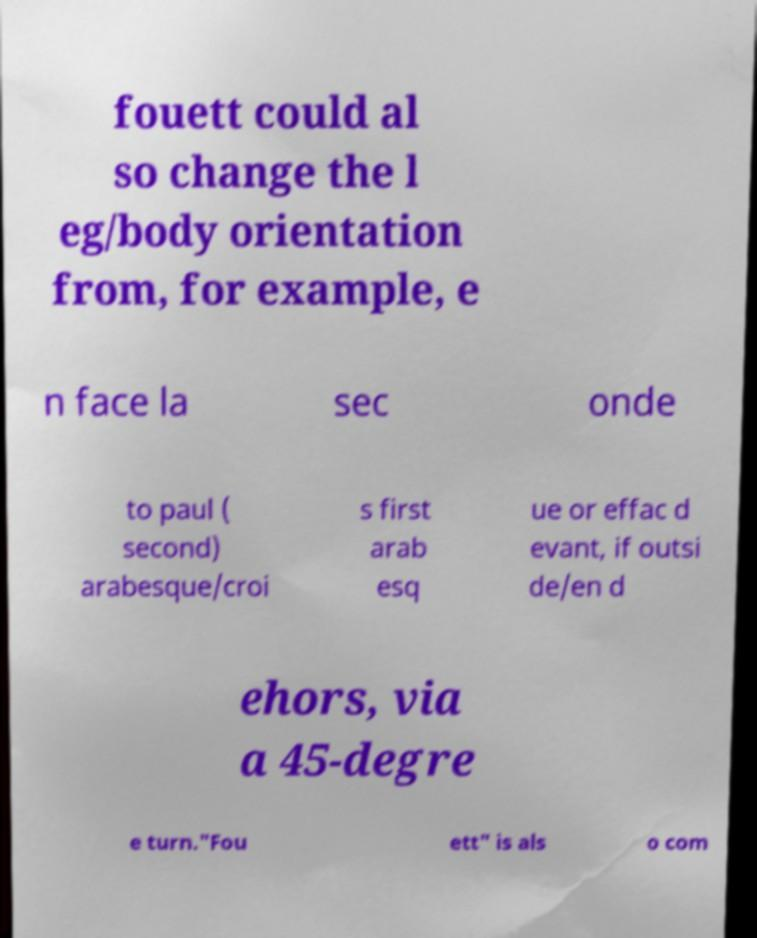For documentation purposes, I need the text within this image transcribed. Could you provide that? fouett could al so change the l eg/body orientation from, for example, e n face la sec onde to paul ( second) arabesque/croi s first arab esq ue or effac d evant, if outsi de/en d ehors, via a 45-degre e turn."Fou ett" is als o com 